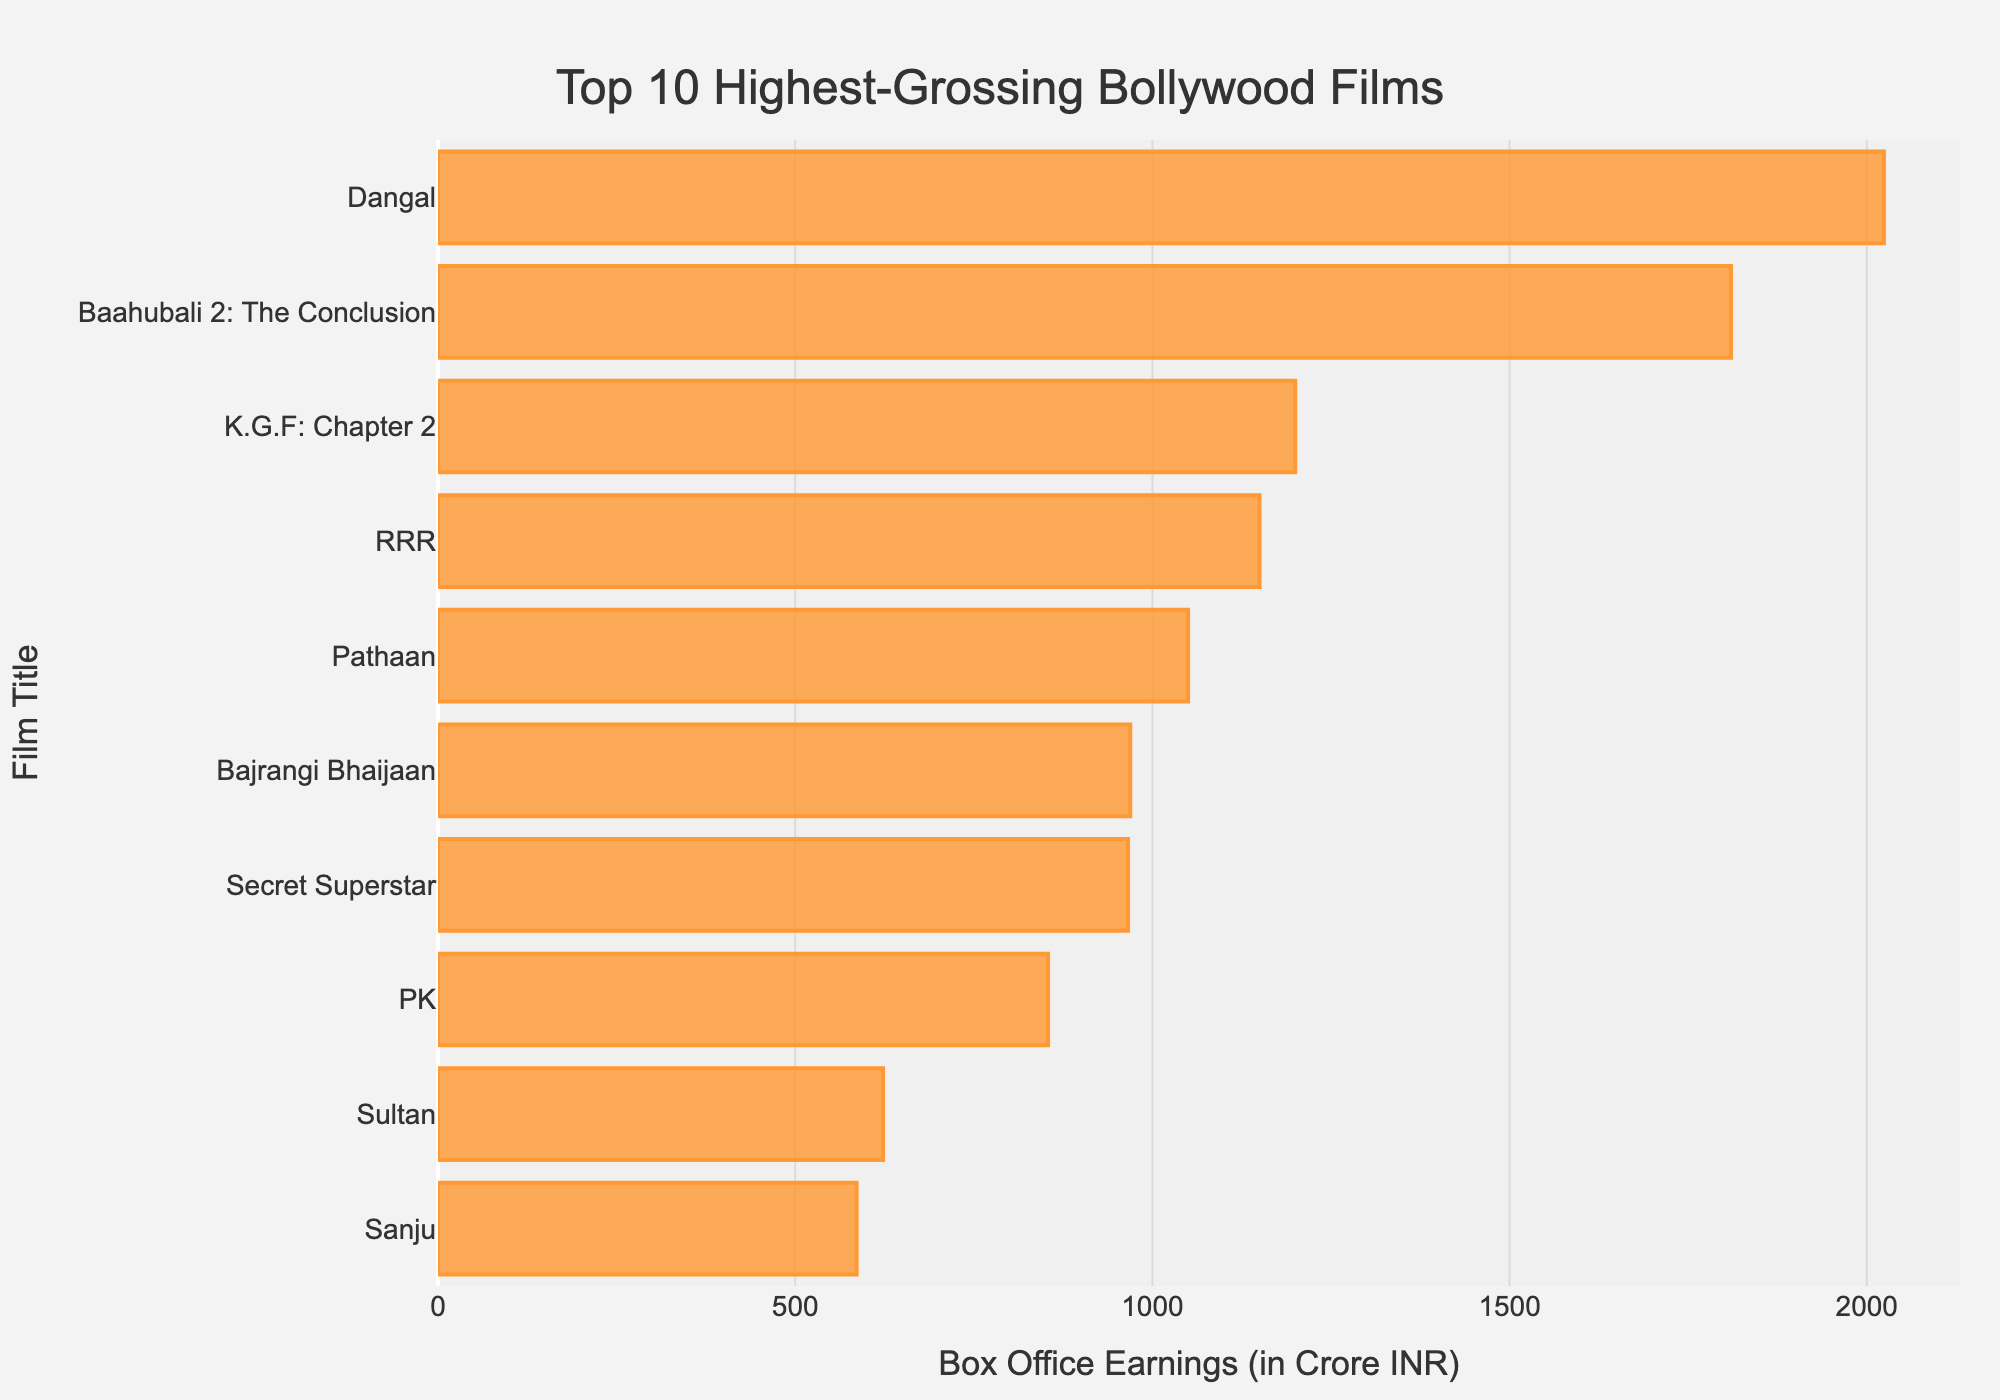Which film has the highest box office earnings? By checking the length of bars in the figure, the longest bar represents the film with the highest earnings. Here, "Dangal" has the longest bar.
Answer: Dangal Which film earned more: "PK" or "Sultan"? Compare the lengths of the bars for "PK" and "Sultan." The bar for "PK" is longer than that for "Sultan," indicating "PK" earned more.
Answer: PK Which films have earnings more than 1000 Crore INR? Check for bars that extend beyond the 1000 Crore INR mark. "Dangal," "Baahubali 2: The Conclusion," "K.G.F: Chapter 2," "RRR," and "Pathaan" all exceed this threshold.
Answer: Dangal, Baahubali 2: The Conclusion, K.G.F: Chapter 2, RRR, Pathaan What is the total box office earnings for the top 2 highest-grossing films combined? The top 2 films are "Dangal" and "Baahubali 2: The Conclusion." Add their earnings: 2024 + 1810 = 3834 Crore INR.
Answer: 3834 Crore INR How much more did "Dangal" earn compared to "Sanju"? Subtract the earnings of "Sanju" from those of "Dangal": 2024 - 586 = 1438 Crore INR.
Answer: 1438 Crore INR What is the average box office earnings of all 10 films listed? Sum all earnings and divide by the number of films: (2024 + 1810 + 1200 + 1150 + 1050 + 969 + 966 + 854 + 623 + 586) / 10 = 1123.2 Crore INR.
Answer: 1123.2 Crore INR Are there any films with earnings less than 700 Crore INR? Check for bars that fall short of the 700 Crore INR mark. "Sultan" and "Sanju" both have earnings less than 700 Crore INR.
Answer: Sultan, Sanju Which films' earnings lie between 900 and 1000 Crore INR? Identify bars that fall within the 900-1000 Crore INR range. Both "Bajrangi Bhaijaan" and "Secret Superstar" fit this criterion.
Answer: Bajrangi Bhaijaan, Secret Superstar What is the difference in box office earnings between the 3rd and 4th highest-grossing films? The 3rd highest-grossing film "K.G.F: Chapter 2" earned 1200 Crore INR and the 4th "RRR" earned 1150 Crore INR. The difference is 1200 - 1150 = 50 Crore INR.
Answer: 50 Crore INR Which film at the 5th position in box office earnings is represented with a shorter bar than "RRR"? "Pathaan" is the 5th film, and it has a shorter bar compared to "RRR."
Answer: Pathaan 